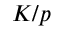<formula> <loc_0><loc_0><loc_500><loc_500>K / p</formula> 